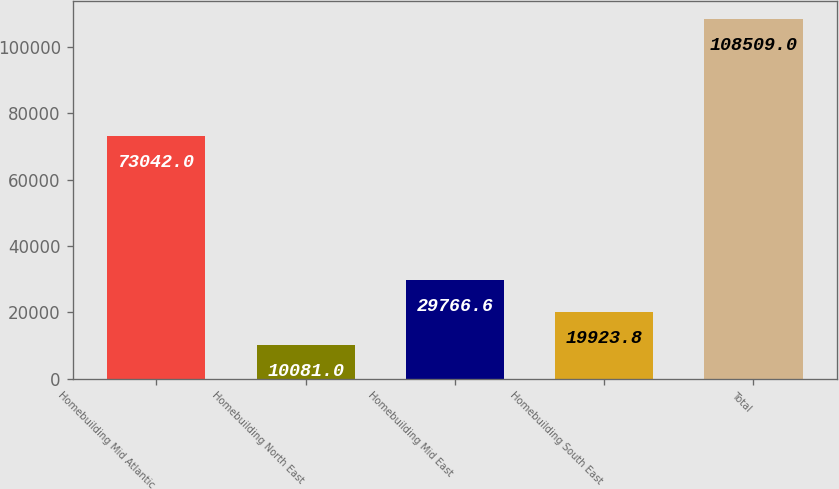Convert chart to OTSL. <chart><loc_0><loc_0><loc_500><loc_500><bar_chart><fcel>Homebuilding Mid Atlantic<fcel>Homebuilding North East<fcel>Homebuilding Mid East<fcel>Homebuilding South East<fcel>Total<nl><fcel>73042<fcel>10081<fcel>29766.6<fcel>19923.8<fcel>108509<nl></chart> 